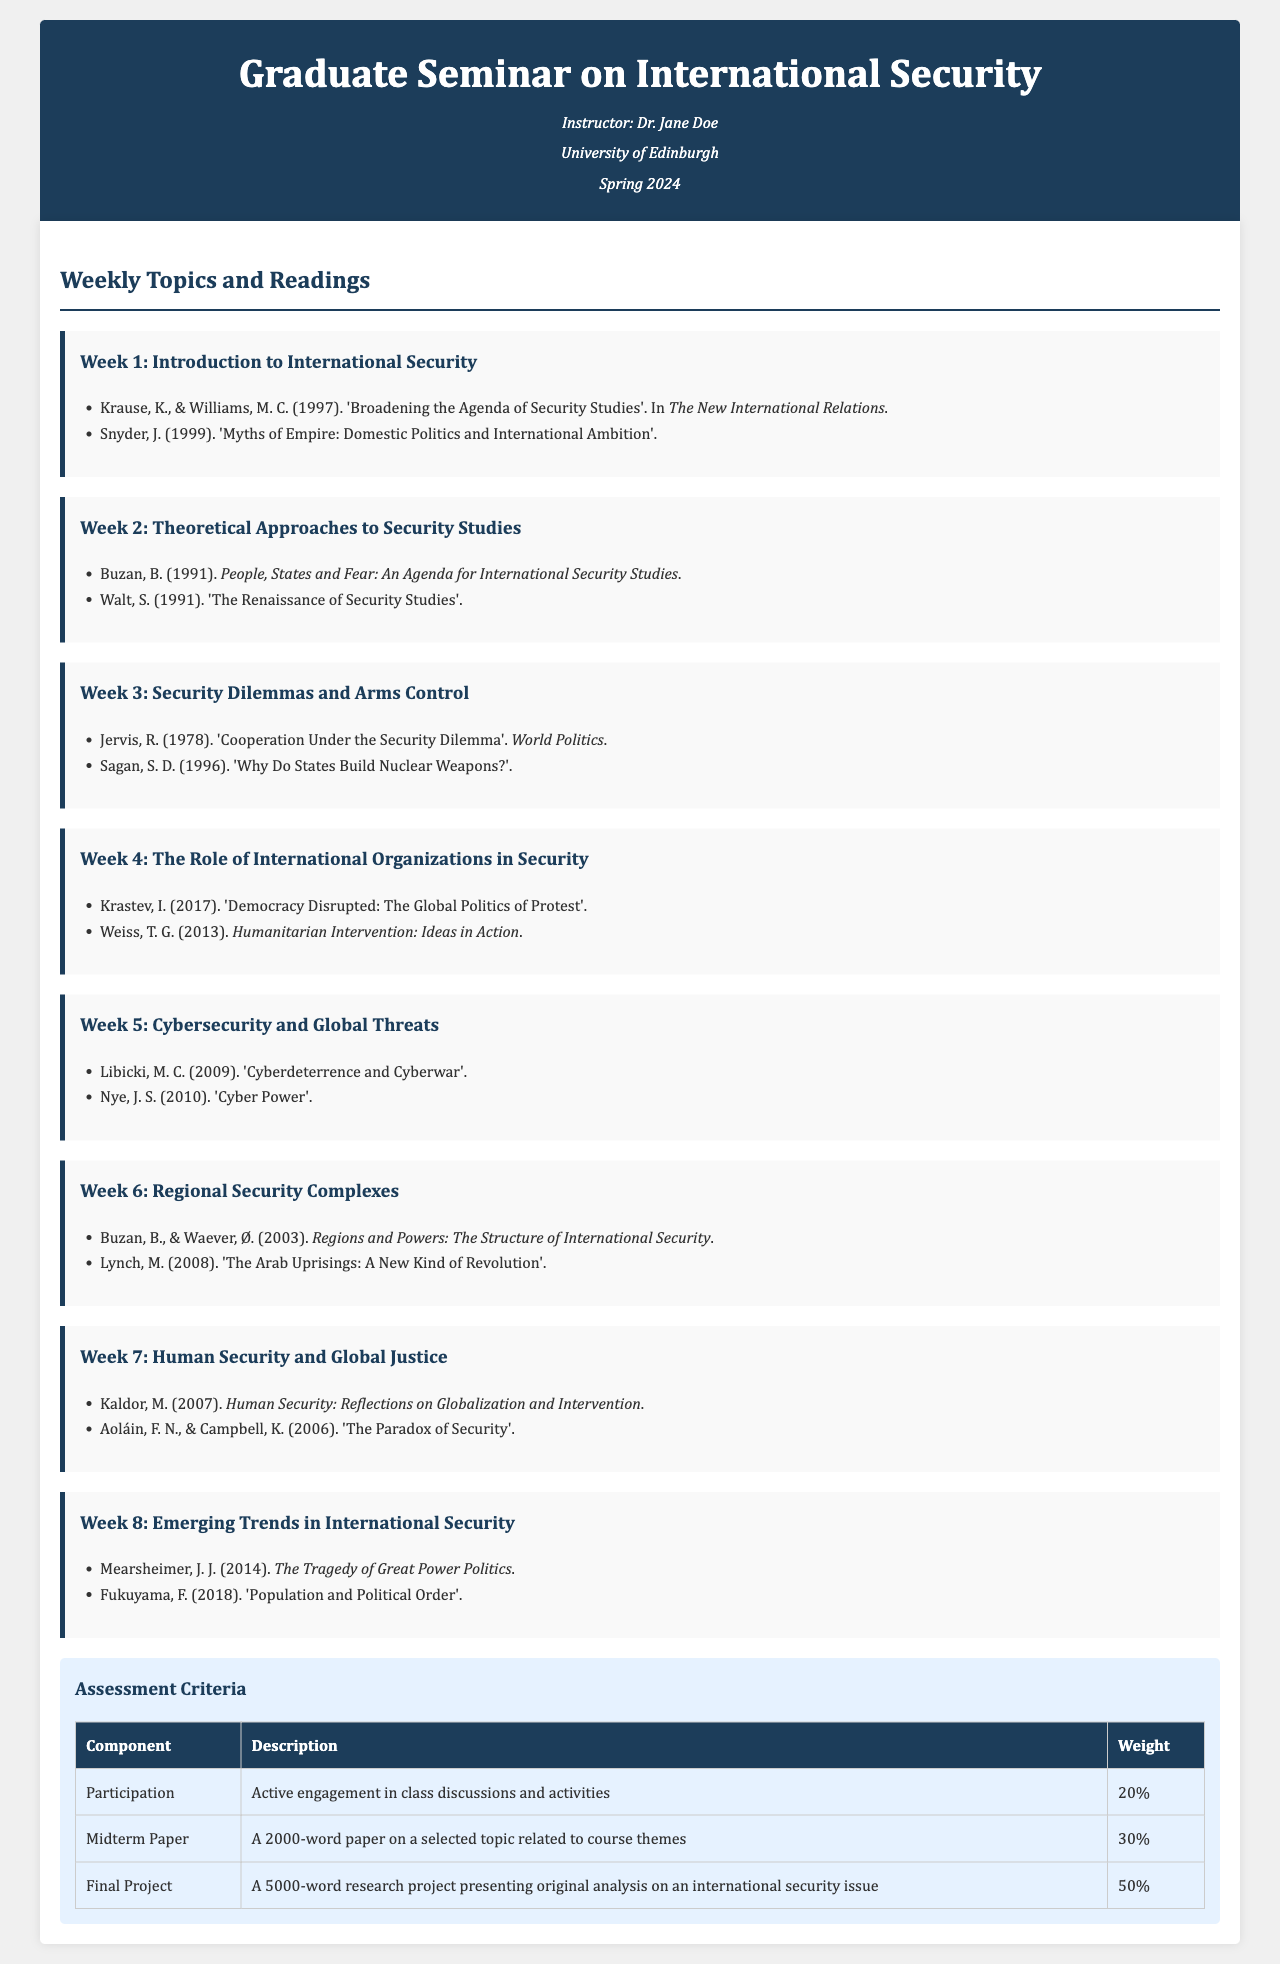What is the title of the seminar? The title of the seminar is stated at the beginning of the document as "Graduate Seminar on International Security."
Answer: Graduate Seminar on International Security Who is the instructor of the course? The name of the instructor is mentioned in the header section.
Answer: Dr. Jane Doe Which week focuses on cybersecurity? The week that discusses cybersecurity is clearly indicated as Week 5.
Answer: Week 5 What is the weight of the final project in the assessment criteria? The weight of the final project is given in the assessment table.
Answer: 50% Name one reading assigned for Week 3. The readings for Week 3 are listed, and one is specified as 'Cooperation Under the Security Dilemma.'
Answer: Cooperation Under the Security Dilemma What is the total word count required for the Midterm Paper? The requirement for the Midterm Paper's length is specified in the assessment criteria.
Answer: 2000-word Which reading discusses international organizations in Week 4? One of the readings for Week 4 is mentioned in the week overview.
Answer: Humanitarian Intervention: Ideas in Action How many weeks are there in the seminar? The number of weekly topics can be counted from the weekly section of the document.
Answer: 8 weeks 